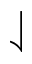Convert formula to latex. <formula><loc_0><loc_0><loc_500><loc_500>\downharpoonleft</formula> 